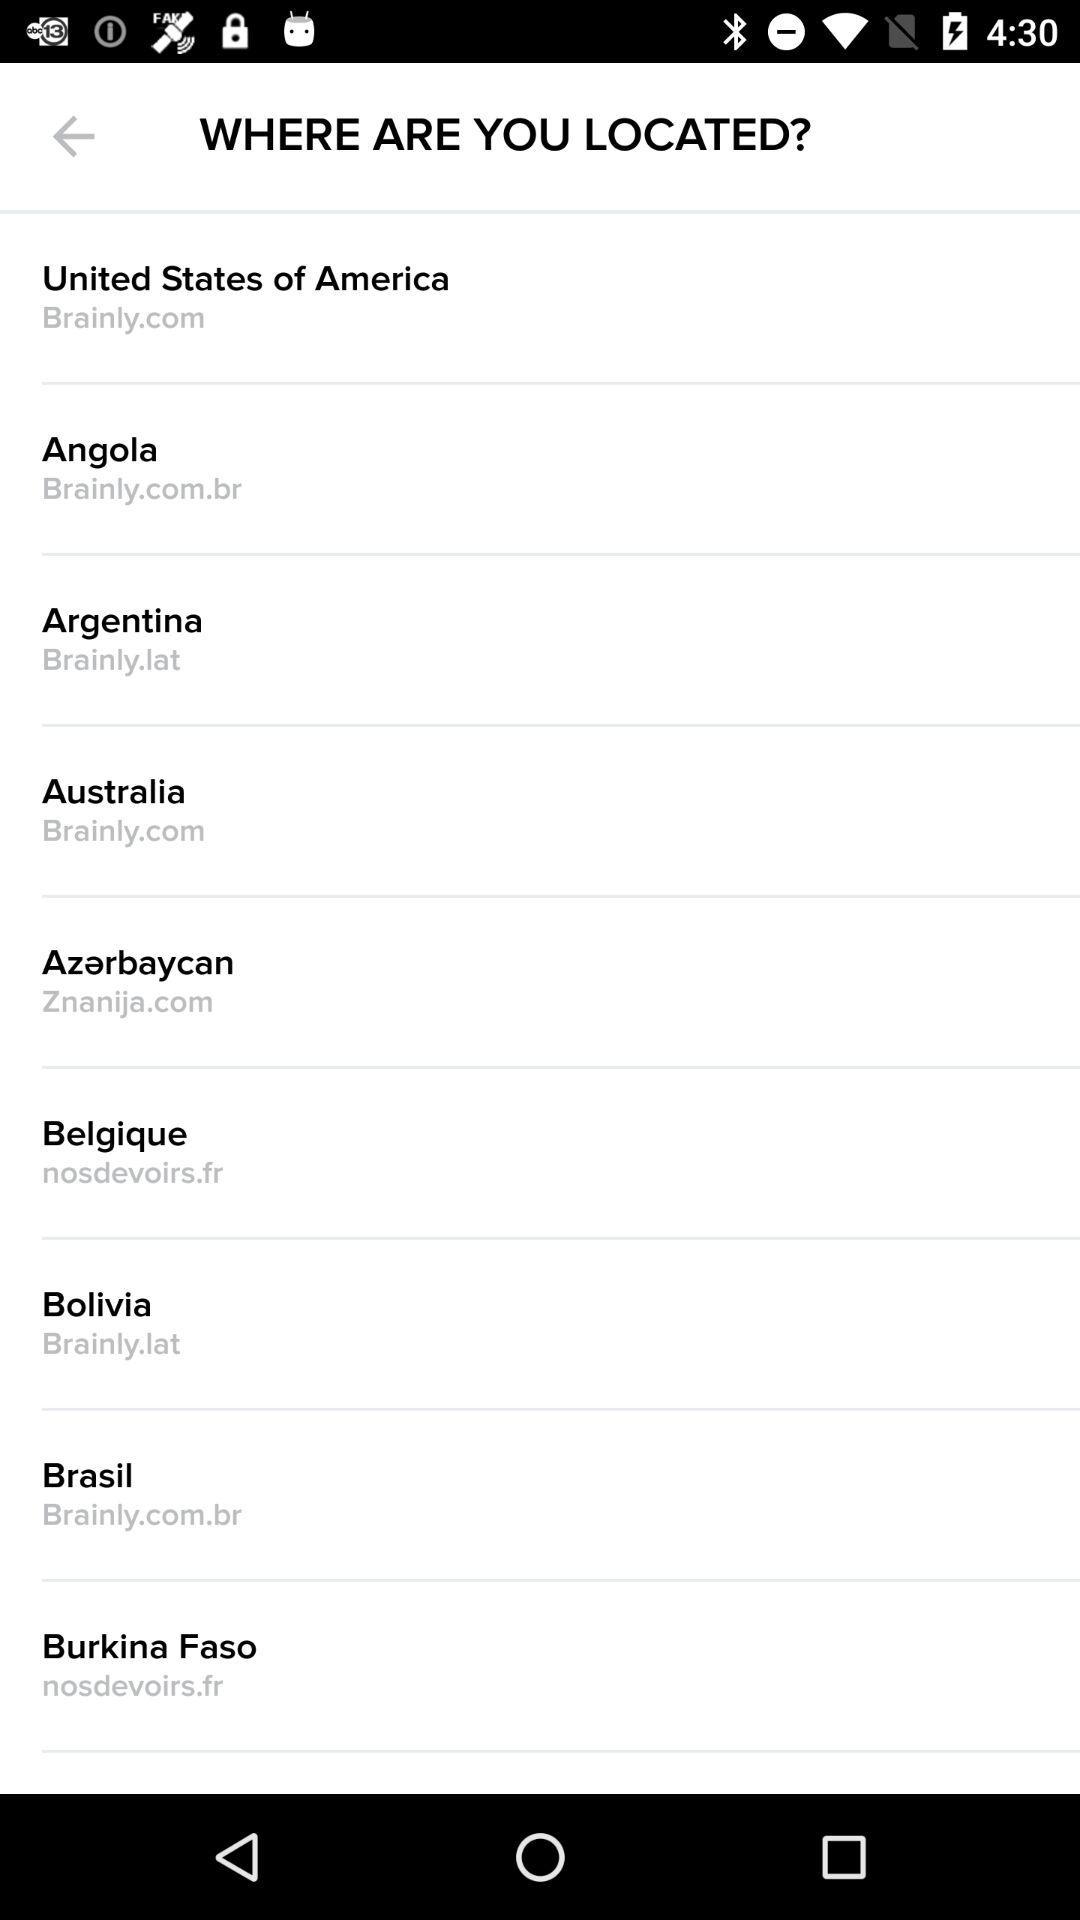What are the available countries? The available countries are the United States of America, Angola, Argentina, Australia, Azerbaycan, Belgique, Bolivia, Brasil and Burkina Faso. 